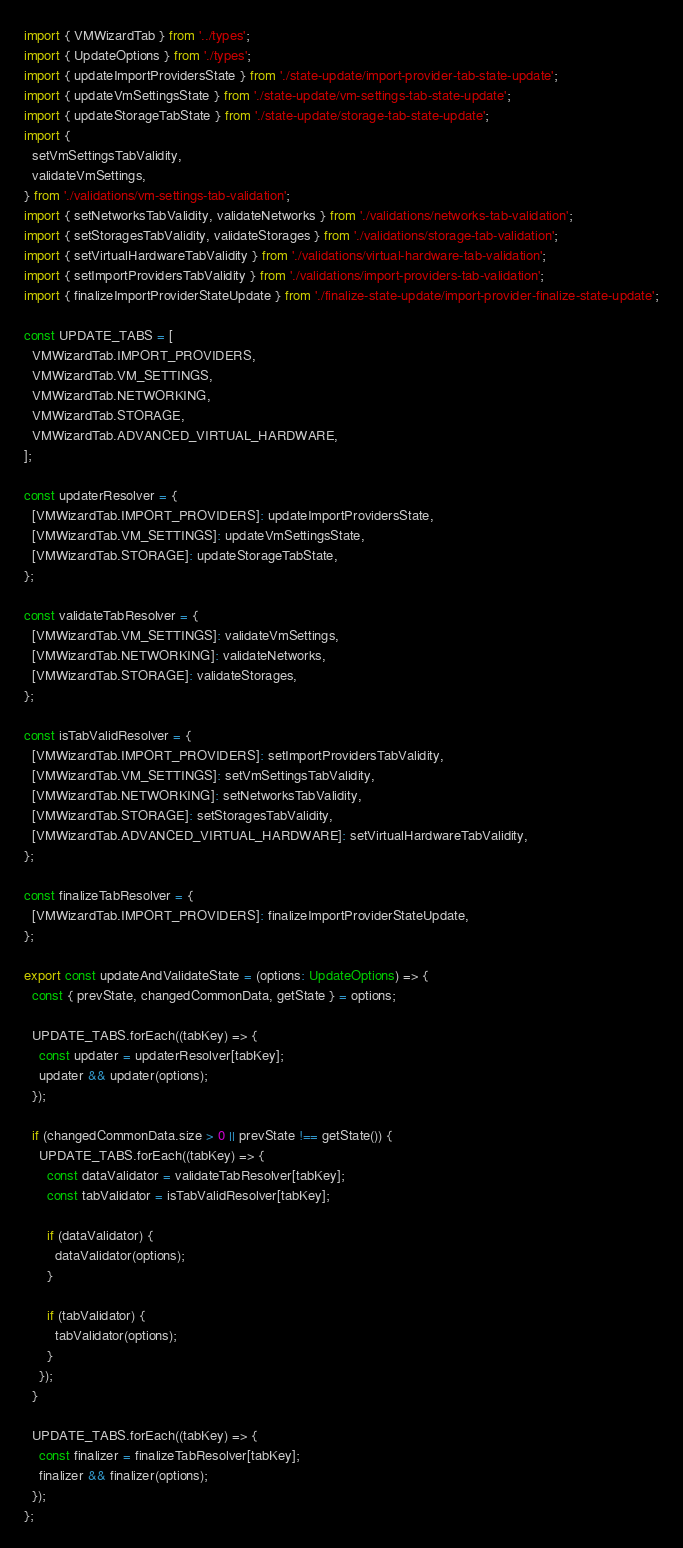<code> <loc_0><loc_0><loc_500><loc_500><_TypeScript_>import { VMWizardTab } from '../types';
import { UpdateOptions } from './types';
import { updateImportProvidersState } from './state-update/import-provider-tab-state-update';
import { updateVmSettingsState } from './state-update/vm-settings-tab-state-update';
import { updateStorageTabState } from './state-update/storage-tab-state-update';
import {
  setVmSettingsTabValidity,
  validateVmSettings,
} from './validations/vm-settings-tab-validation';
import { setNetworksTabValidity, validateNetworks } from './validations/networks-tab-validation';
import { setStoragesTabValidity, validateStorages } from './validations/storage-tab-validation';
import { setVirtualHardwareTabValidity } from './validations/virtual-hardware-tab-validation';
import { setImportProvidersTabValidity } from './validations/import-providers-tab-validation';
import { finalizeImportProviderStateUpdate } from './finalize-state-update/import-provider-finalize-state-update';

const UPDATE_TABS = [
  VMWizardTab.IMPORT_PROVIDERS,
  VMWizardTab.VM_SETTINGS,
  VMWizardTab.NETWORKING,
  VMWizardTab.STORAGE,
  VMWizardTab.ADVANCED_VIRTUAL_HARDWARE,
];

const updaterResolver = {
  [VMWizardTab.IMPORT_PROVIDERS]: updateImportProvidersState,
  [VMWizardTab.VM_SETTINGS]: updateVmSettingsState,
  [VMWizardTab.STORAGE]: updateStorageTabState,
};

const validateTabResolver = {
  [VMWizardTab.VM_SETTINGS]: validateVmSettings,
  [VMWizardTab.NETWORKING]: validateNetworks,
  [VMWizardTab.STORAGE]: validateStorages,
};

const isTabValidResolver = {
  [VMWizardTab.IMPORT_PROVIDERS]: setImportProvidersTabValidity,
  [VMWizardTab.VM_SETTINGS]: setVmSettingsTabValidity,
  [VMWizardTab.NETWORKING]: setNetworksTabValidity,
  [VMWizardTab.STORAGE]: setStoragesTabValidity,
  [VMWizardTab.ADVANCED_VIRTUAL_HARDWARE]: setVirtualHardwareTabValidity,
};

const finalizeTabResolver = {
  [VMWizardTab.IMPORT_PROVIDERS]: finalizeImportProviderStateUpdate,
};

export const updateAndValidateState = (options: UpdateOptions) => {
  const { prevState, changedCommonData, getState } = options;

  UPDATE_TABS.forEach((tabKey) => {
    const updater = updaterResolver[tabKey];
    updater && updater(options);
  });

  if (changedCommonData.size > 0 || prevState !== getState()) {
    UPDATE_TABS.forEach((tabKey) => {
      const dataValidator = validateTabResolver[tabKey];
      const tabValidator = isTabValidResolver[tabKey];

      if (dataValidator) {
        dataValidator(options);
      }

      if (tabValidator) {
        tabValidator(options);
      }
    });
  }

  UPDATE_TABS.forEach((tabKey) => {
    const finalizer = finalizeTabResolver[tabKey];
    finalizer && finalizer(options);
  });
};
</code> 